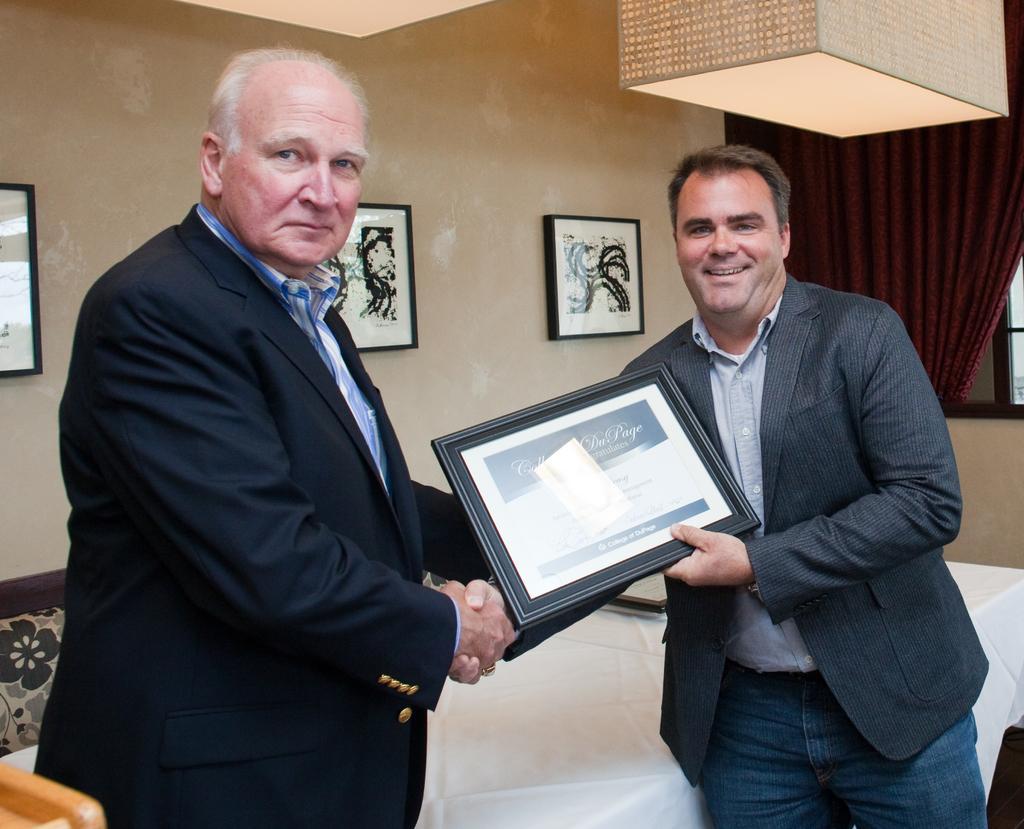Can you describe this image briefly? In this picture I can see there are two men standing and the person on to left is wearing a blazer and smiling and the person to the right is shaking hands and he is wearing a blazer and holding a certificate. In the backdrop there is a table and there are few photo frames placed on the wall and there are lights attached to the ceiling. There is a curtain on to right side. 